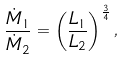Convert formula to latex. <formula><loc_0><loc_0><loc_500><loc_500>\frac { \dot { M } _ { 1 } } { \dot { M } _ { 2 } } = \left ( \frac { L _ { 1 } } { L _ { 2 } } \right ) ^ { \frac { 3 } { 4 } } ,</formula> 